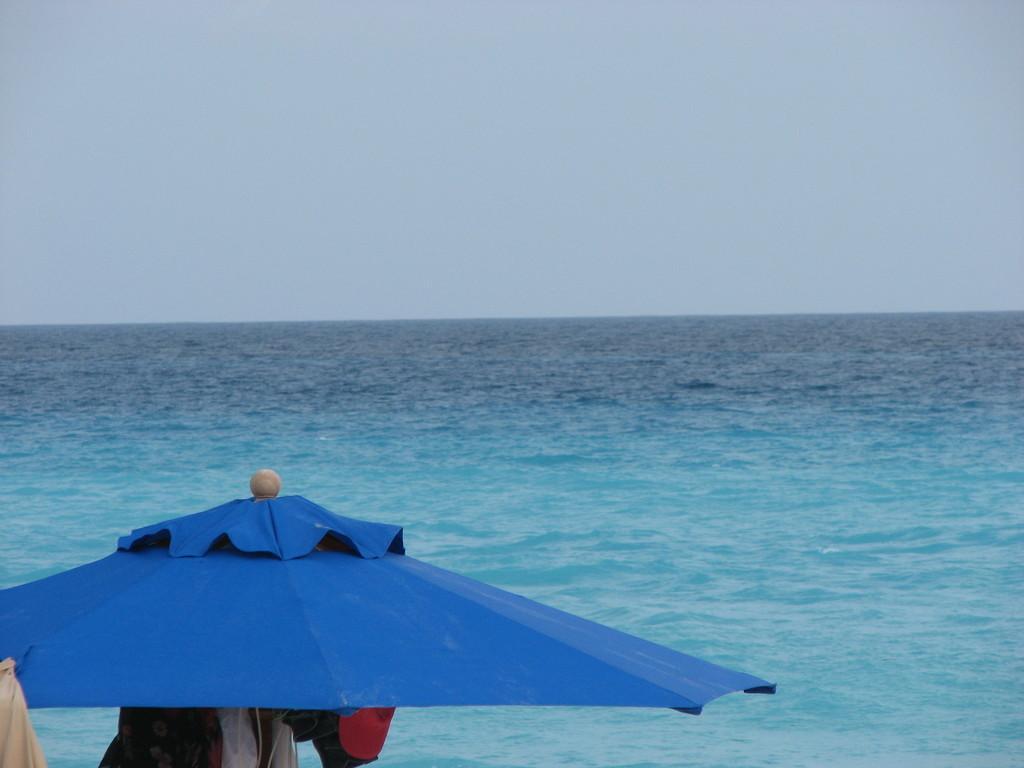Describe this image in one or two sentences. On the left side bottom of the image, we can see an umbrella and clothes. In the background, we can see the water and sky. 